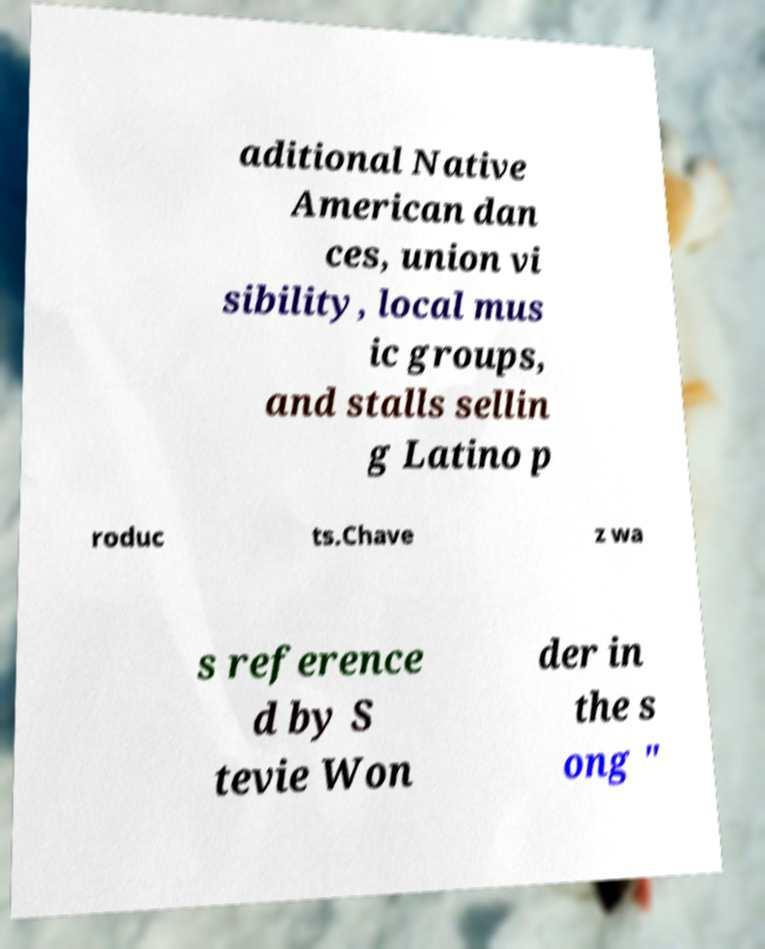Can you read and provide the text displayed in the image?This photo seems to have some interesting text. Can you extract and type it out for me? aditional Native American dan ces, union vi sibility, local mus ic groups, and stalls sellin g Latino p roduc ts.Chave z wa s reference d by S tevie Won der in the s ong " 